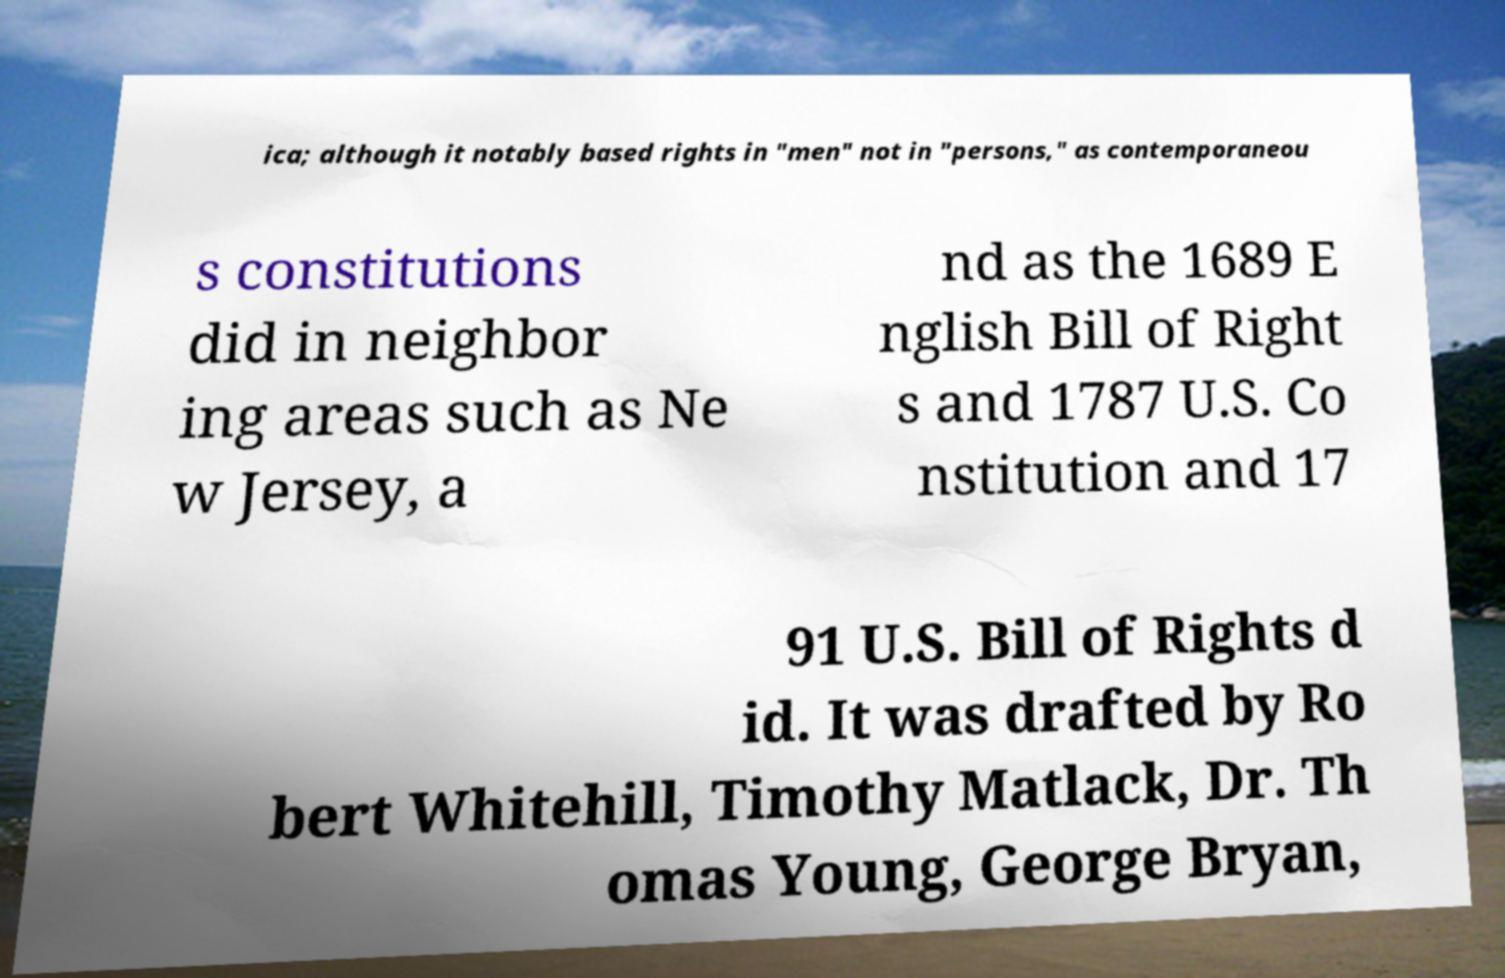For documentation purposes, I need the text within this image transcribed. Could you provide that? ica; although it notably based rights in "men" not in "persons," as contemporaneou s constitutions did in neighbor ing areas such as Ne w Jersey, a nd as the 1689 E nglish Bill of Right s and 1787 U.S. Co nstitution and 17 91 U.S. Bill of Rights d id. It was drafted by Ro bert Whitehill, Timothy Matlack, Dr. Th omas Young, George Bryan, 